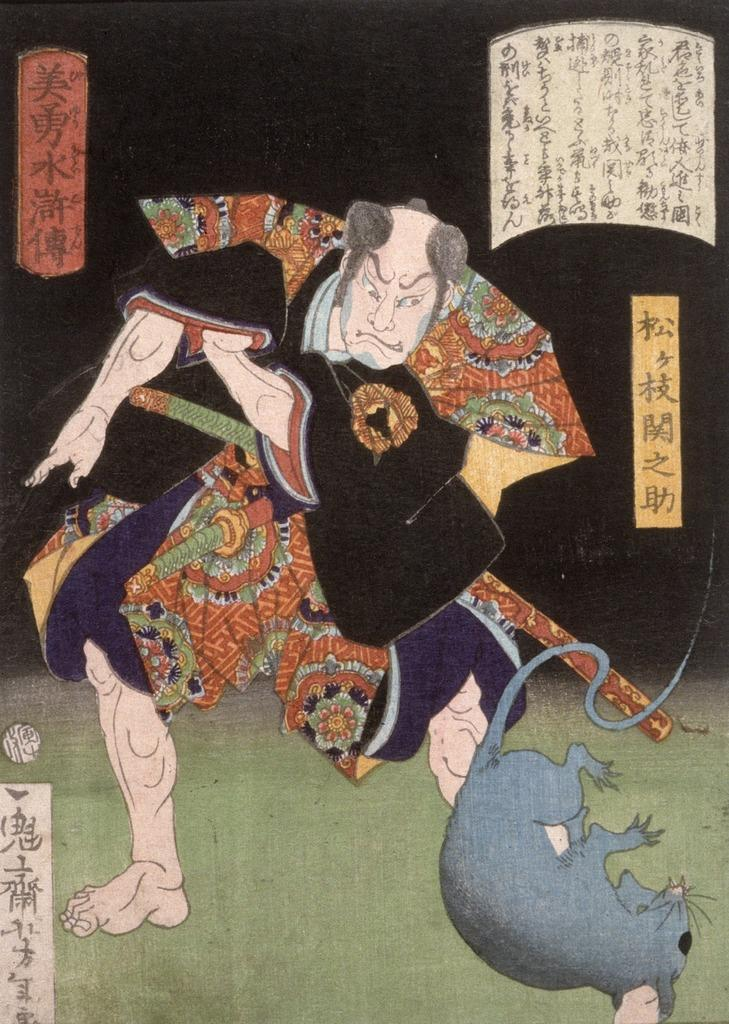What is the main subject of the image? There is an art piece in the image. Can you describe the art piece? The art piece has text on it. How many women are depicted in the art piece? There is no information about women or any other figures in the art piece, as the facts only mention the presence of text. 